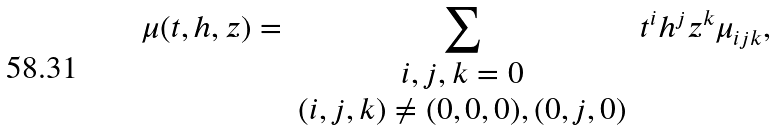Convert formula to latex. <formula><loc_0><loc_0><loc_500><loc_500>\mu ( t , h , z ) = \sum _ { \begin{array} { c } i , j , k = 0 \\ ( i , j , k ) \neq ( 0 , 0 , 0 ) , ( 0 , j , 0 ) \end{array} } t ^ { i } h ^ { j } z ^ { k } \mu _ { i j k } ,</formula> 